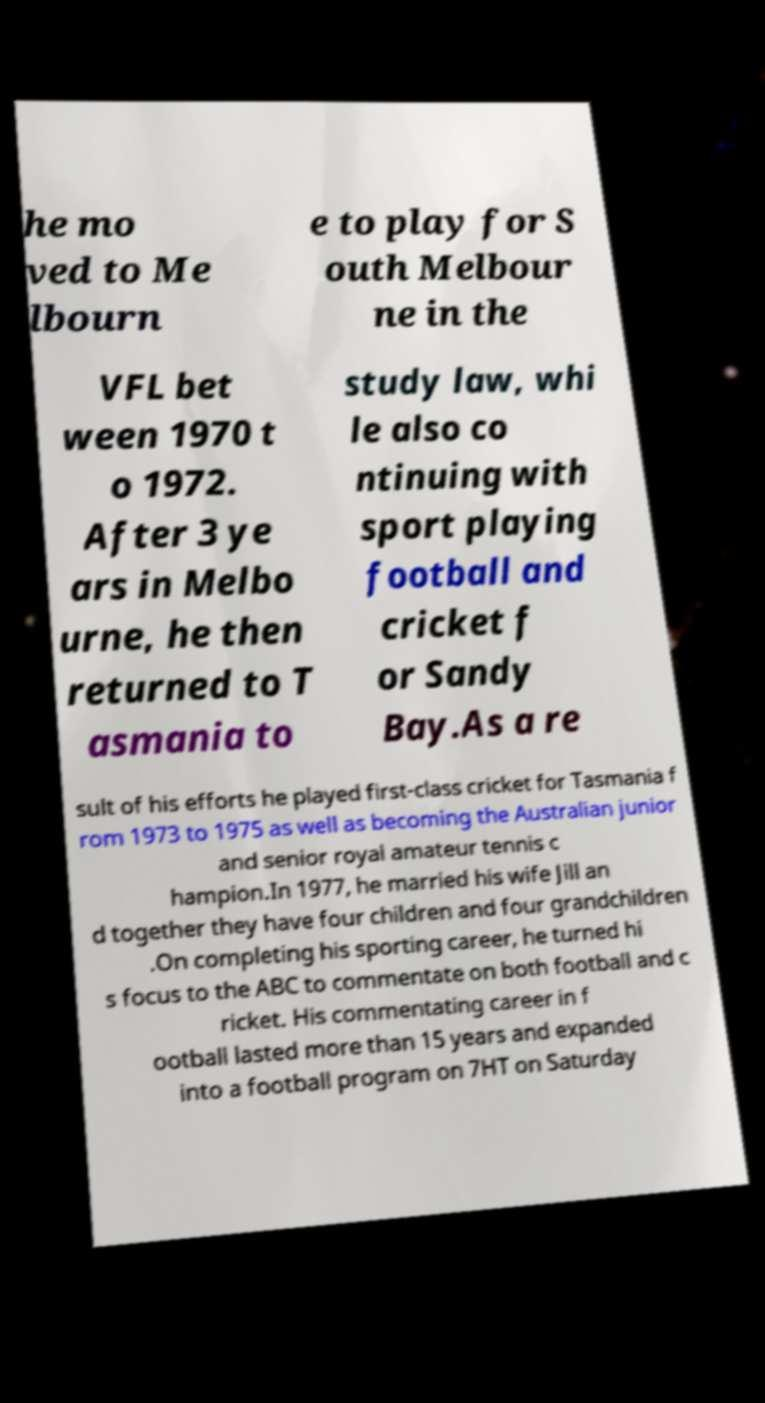There's text embedded in this image that I need extracted. Can you transcribe it verbatim? he mo ved to Me lbourn e to play for S outh Melbour ne in the VFL bet ween 1970 t o 1972. After 3 ye ars in Melbo urne, he then returned to T asmania to study law, whi le also co ntinuing with sport playing football and cricket f or Sandy Bay.As a re sult of his efforts he played first-class cricket for Tasmania f rom 1973 to 1975 as well as becoming the Australian junior and senior royal amateur tennis c hampion.In 1977, he married his wife Jill an d together they have four children and four grandchildren .On completing his sporting career, he turned hi s focus to the ABC to commentate on both football and c ricket. His commentating career in f ootball lasted more than 15 years and expanded into a football program on 7HT on Saturday 